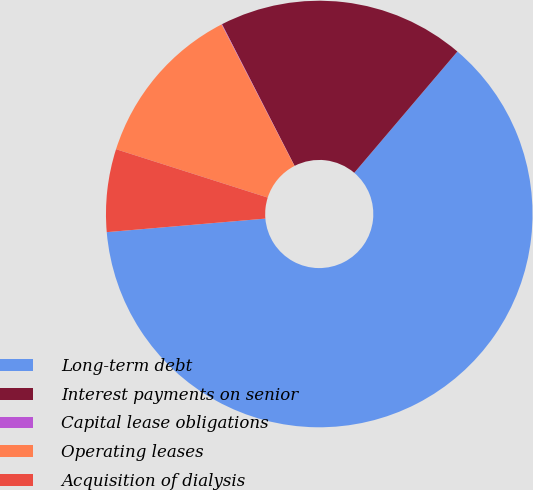<chart> <loc_0><loc_0><loc_500><loc_500><pie_chart><fcel>Long-term debt<fcel>Interest payments on senior<fcel>Capital lease obligations<fcel>Operating leases<fcel>Acquisition of dialysis<nl><fcel>62.43%<fcel>18.75%<fcel>0.04%<fcel>12.51%<fcel>6.27%<nl></chart> 